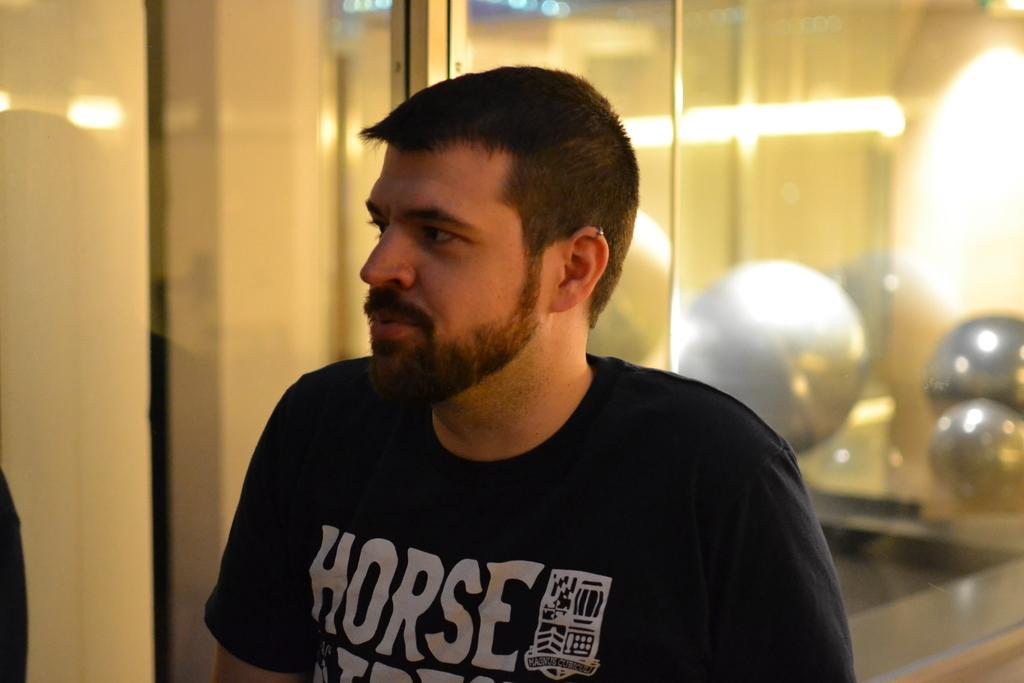Who is present in the image? There is a man in the image. What is the man wearing? The man is wearing a t-shirt. What can be seen in the background of the image? There is a wall in the background of the image. What else is visible in the image? There are lights visible in the image. What song is the man singing in the image? There is no indication in the image that the man is singing a song, so it cannot be determined from the picture. 